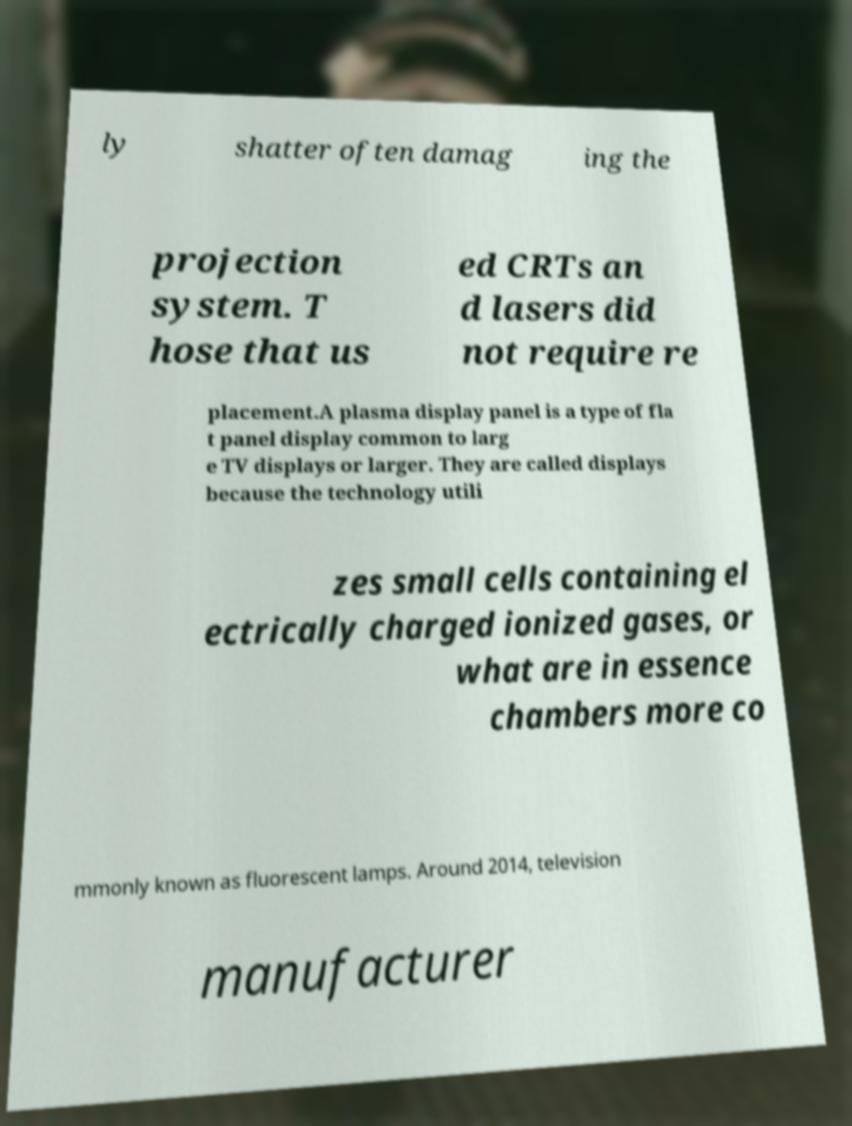There's text embedded in this image that I need extracted. Can you transcribe it verbatim? ly shatter often damag ing the projection system. T hose that us ed CRTs an d lasers did not require re placement.A plasma display panel is a type of fla t panel display common to larg e TV displays or larger. They are called displays because the technology utili zes small cells containing el ectrically charged ionized gases, or what are in essence chambers more co mmonly known as fluorescent lamps. Around 2014, television manufacturer 